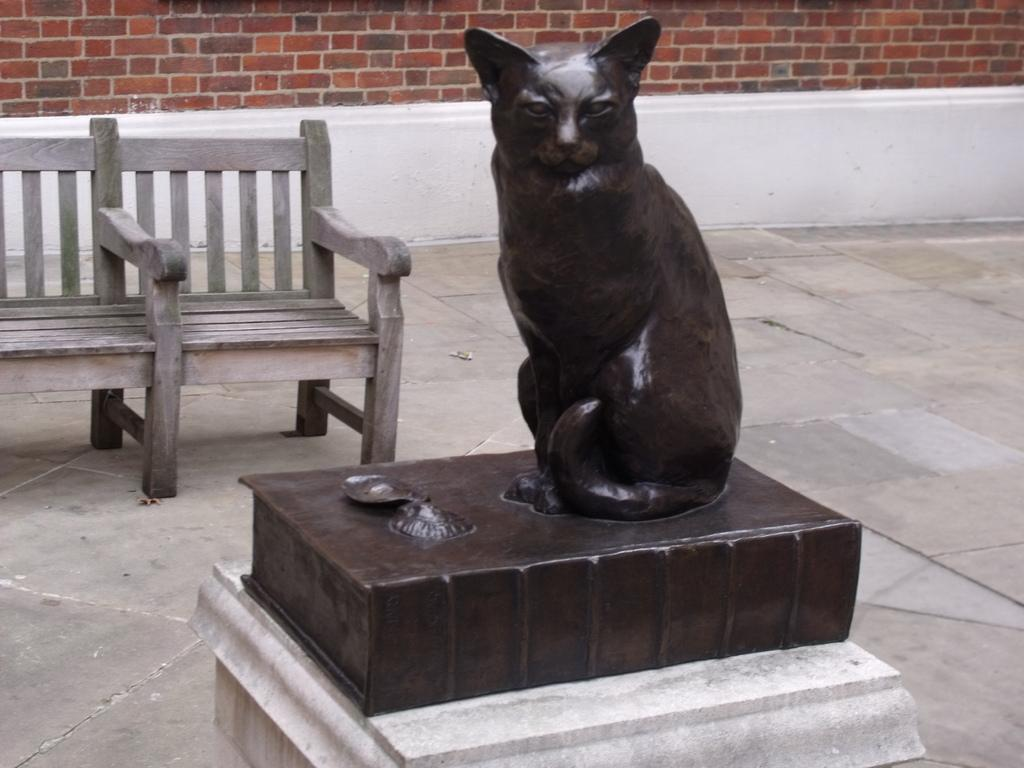What is the main subject of the image? There is a sculpture in the image. Can you describe the appearance of the sculpture? The sculpture is black in color. What other object is present in the image? There is a bench in the image. What material is the wall made of in the image? The wall in the image is made of bricks. What type of volleyball game is being played in the image? There is no volleyball game present in the image. Can you tell me who the father is in the image? There is no reference to a father or any people in the image. 